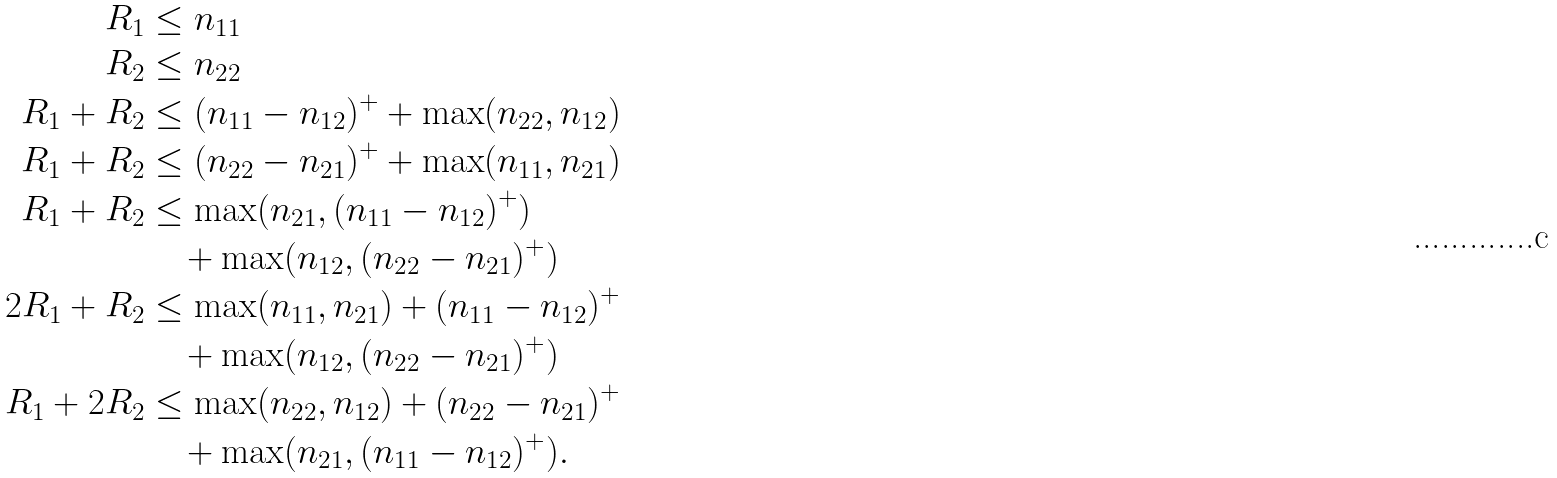<formula> <loc_0><loc_0><loc_500><loc_500>R _ { 1 } & \leq n _ { 1 1 } \\ R _ { 2 } & \leq n _ { 2 2 } \\ R _ { 1 } + R _ { 2 } & \leq ( n _ { 1 1 } - n _ { 1 2 } ) ^ { + } + \max ( n _ { 2 2 } , n _ { 1 2 } ) \\ R _ { 1 } + R _ { 2 } & \leq ( n _ { 2 2 } - n _ { 2 1 } ) ^ { + } + \max ( n _ { 1 1 } , n _ { 2 1 } ) \\ R _ { 1 } + R _ { 2 } & \leq \max ( n _ { 2 1 } , ( n _ { 1 1 } - n _ { 1 2 } ) ^ { + } ) \\ & \quad + \max ( n _ { 1 2 } , ( n _ { 2 2 } - n _ { 2 1 } ) ^ { + } ) \\ 2 R _ { 1 } + R _ { 2 } & \leq \max ( n _ { 1 1 } , n _ { 2 1 } ) + ( n _ { 1 1 } - n _ { 1 2 } ) ^ { + } \\ & \quad + \max ( n _ { 1 2 } , ( n _ { 2 2 } - n _ { 2 1 } ) ^ { + } ) \\ R _ { 1 } + 2 R _ { 2 } & \leq \max ( n _ { 2 2 } , n _ { 1 2 } ) + ( n _ { 2 2 } - n _ { 2 1 } ) ^ { + } \\ & \quad + \max ( n _ { 2 1 } , ( n _ { 1 1 } - n _ { 1 2 } ) ^ { + } ) .</formula> 